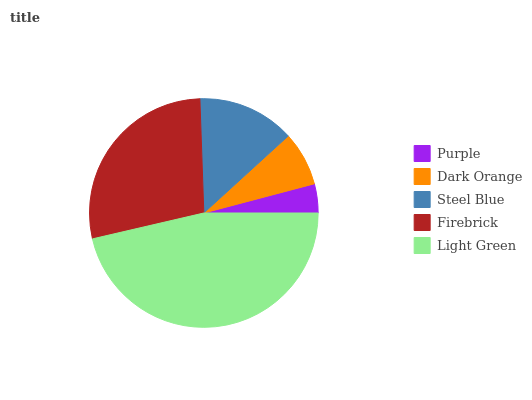Is Purple the minimum?
Answer yes or no. Yes. Is Light Green the maximum?
Answer yes or no. Yes. Is Dark Orange the minimum?
Answer yes or no. No. Is Dark Orange the maximum?
Answer yes or no. No. Is Dark Orange greater than Purple?
Answer yes or no. Yes. Is Purple less than Dark Orange?
Answer yes or no. Yes. Is Purple greater than Dark Orange?
Answer yes or no. No. Is Dark Orange less than Purple?
Answer yes or no. No. Is Steel Blue the high median?
Answer yes or no. Yes. Is Steel Blue the low median?
Answer yes or no. Yes. Is Light Green the high median?
Answer yes or no. No. Is Dark Orange the low median?
Answer yes or no. No. 